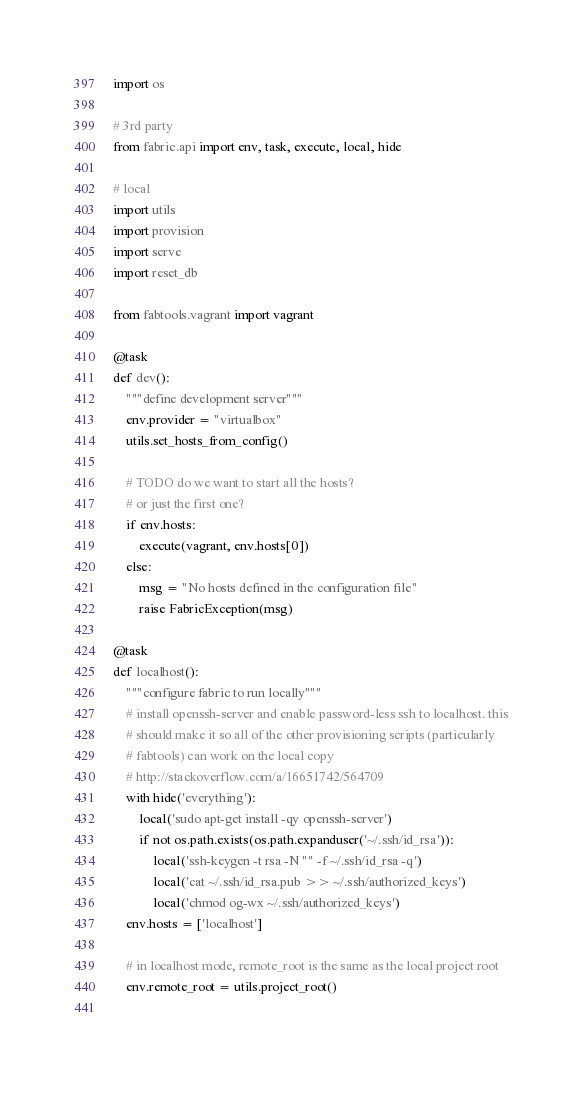Convert code to text. <code><loc_0><loc_0><loc_500><loc_500><_Python_>import os

# 3rd party
from fabric.api import env, task, execute, local, hide

# local
import utils
import provision
import serve
import reset_db

from fabtools.vagrant import vagrant

@task
def dev():
    """define development server"""
    env.provider = "virtualbox"
    utils.set_hosts_from_config()
    
    # TODO do we want to start all the hosts?
    # or just the first one?
    if env.hosts:
        execute(vagrant, env.hosts[0])
    else:
        msg = "No hosts defined in the configuration file"
        raise FabricException(msg)

@task
def localhost():
    """configure fabric to run locally"""
    # install openssh-server and enable password-less ssh to localhost. this
    # should make it so all of the other provisioning scripts (particularly
    # fabtools) can work on the local copy
    # http://stackoverflow.com/a/16651742/564709
    with hide('everything'):
        local('sudo apt-get install -qy openssh-server')
        if not os.path.exists(os.path.expanduser('~/.ssh/id_rsa')):
            local('ssh-keygen -t rsa -N "" -f ~/.ssh/id_rsa -q')
            local('cat ~/.ssh/id_rsa.pub >> ~/.ssh/authorized_keys')
            local('chmod og-wx ~/.ssh/authorized_keys')
    env.hosts = ['localhost']

    # in localhost mode, remote_root is the same as the local project root
    env.remote_root = utils.project_root()
    
</code> 